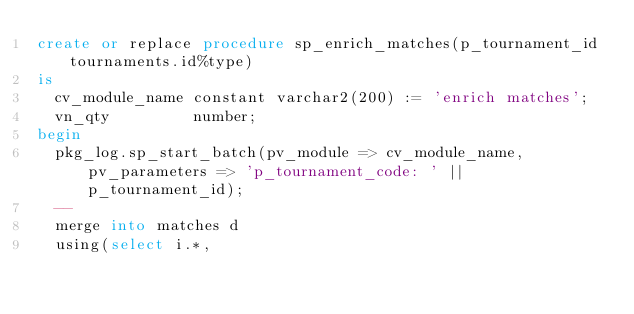<code> <loc_0><loc_0><loc_500><loc_500><_SQL_>create or replace procedure sp_enrich_matches(p_tournament_id tournaments.id%type)
is
  cv_module_name constant varchar2(200) := 'enrich matches';
  vn_qty         number;
begin
  pkg_log.sp_start_batch(pv_module => cv_module_name, pv_parameters => 'p_tournament_code: ' || p_tournament_id);
  --
  merge into matches d
  using(select i.*,</code> 